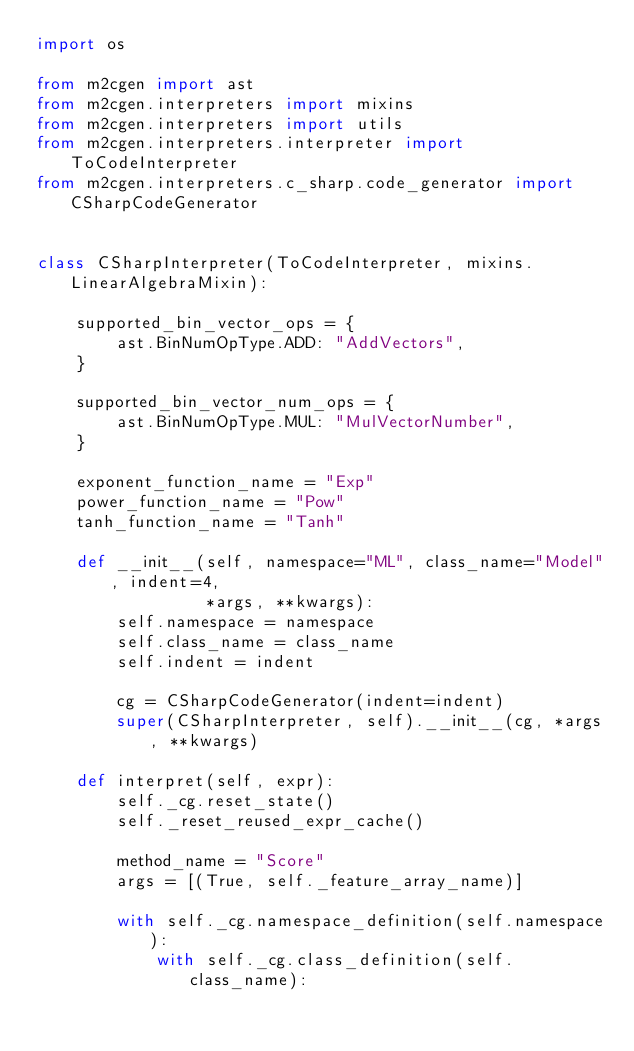Convert code to text. <code><loc_0><loc_0><loc_500><loc_500><_Python_>import os

from m2cgen import ast
from m2cgen.interpreters import mixins
from m2cgen.interpreters import utils
from m2cgen.interpreters.interpreter import ToCodeInterpreter
from m2cgen.interpreters.c_sharp.code_generator import CSharpCodeGenerator


class CSharpInterpreter(ToCodeInterpreter, mixins.LinearAlgebraMixin):

    supported_bin_vector_ops = {
        ast.BinNumOpType.ADD: "AddVectors",
    }

    supported_bin_vector_num_ops = {
        ast.BinNumOpType.MUL: "MulVectorNumber",
    }

    exponent_function_name = "Exp"
    power_function_name = "Pow"
    tanh_function_name = "Tanh"

    def __init__(self, namespace="ML", class_name="Model", indent=4,
                 *args, **kwargs):
        self.namespace = namespace
        self.class_name = class_name
        self.indent = indent

        cg = CSharpCodeGenerator(indent=indent)
        super(CSharpInterpreter, self).__init__(cg, *args, **kwargs)

    def interpret(self, expr):
        self._cg.reset_state()
        self._reset_reused_expr_cache()

        method_name = "Score"
        args = [(True, self._feature_array_name)]

        with self._cg.namespace_definition(self.namespace):
            with self._cg.class_definition(self.class_name):</code> 